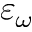<formula> <loc_0><loc_0><loc_500><loc_500>\varepsilon _ { \omega }</formula> 